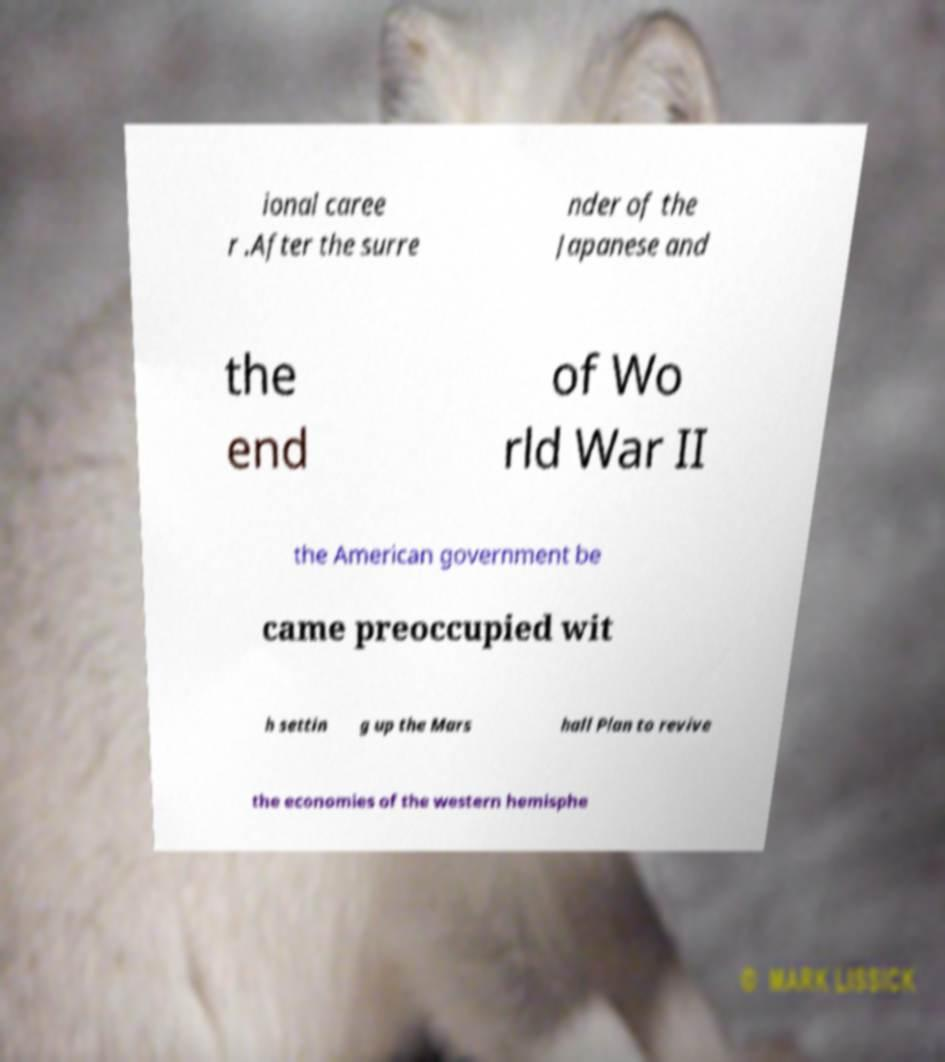Please identify and transcribe the text found in this image. ional caree r .After the surre nder of the Japanese and the end of Wo rld War II the American government be came preoccupied wit h settin g up the Mars hall Plan to revive the economies of the western hemisphe 